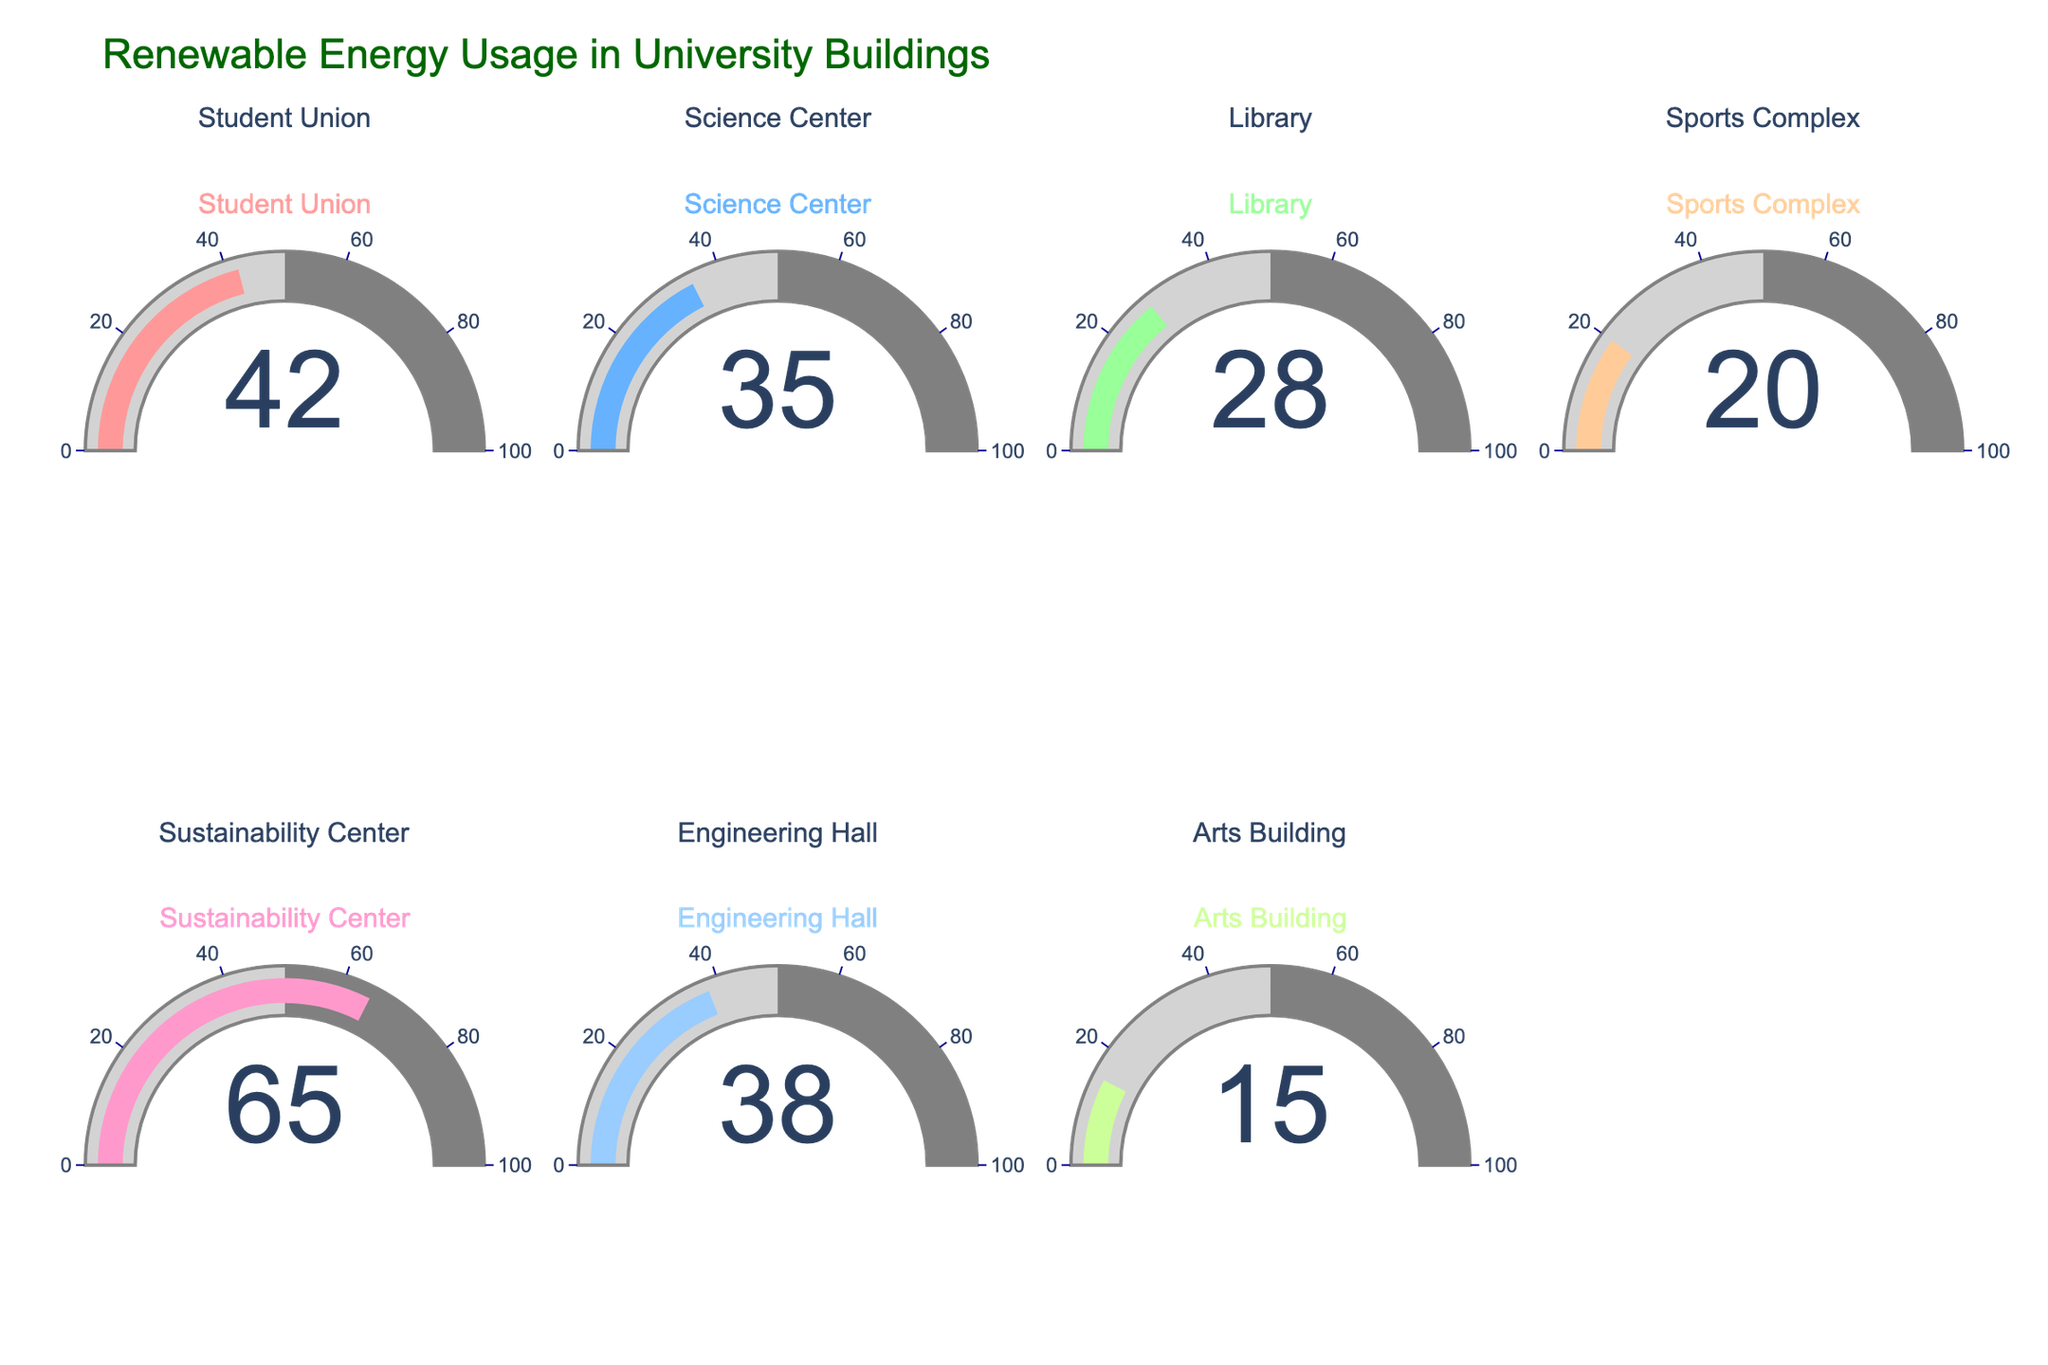What is the title of the figure? The title of the figure is always displayed prominently at the top. It helps give context to what the data visualization is about. In this case, it should summarize the entire chart.
Answer: Renewable Energy Usage in University Buildings Which building has the highest renewable energy usage? To find the building with the highest renewable energy usage, look for the gauge with the largest number. This gauge will indicate the building with the highest percentage.
Answer: Sustainability Center What is the renewable energy usage percentage in the Library? Locate the gauge labeled 'Library' and check the number displayed in the gauge to find the renewable energy usage percentage.
Answer: 28% What is the difference in renewable energy usage between the Student Union and the Arts Building? Identify the percentages of the Student Union and Arts Building from their respective gauges. Subtract the smaller number from the larger number. (42 - 15) = 27
Answer: 27% Is the renewable energy usage in the Science Center greater than that in the Engineering Hall? Compare the percentages on the gauges for the Science Center and Engineering Hall. Science Center has 35 and Engineering Hall has 38. Since 35 < 38, the usage in the Science Center is not greater.
Answer: No What is the average renewable energy usage across all the buildings? Add all the percentages together and divide by the number of buildings: (42 + 35 + 28 + 20 + 65 + 38 + 15) / 7 = 243 / 7 ≈ 34.71
Answer: ≈ 34.71% Which buildings have a renewable energy usage below 30%? Identify and list the buildings with gauges that show less than 30%. From the data, these would be Library, Sports Complex, and Arts Building.
Answer: Library, Sports Complex, Arts Building What is the combined renewable energy usage percentage of the Science Center and Sustainability Center? Sum the percentages of the Science Center (35) and Sustainability Center (65). 35 + 65 = 100
Answer: 100% Is the renewable energy usage in the Student Union less than the usage in the Sustainability Center? Compare the Student Union (42) and Sustainability Center (65) gauge values. Since 42 < 65, the usage in the Student Union is less.
Answer: Yes Which building has the least renewable energy usage and what is the percentage? Find the gauge with the smallest value to determine which building has the least renewable energy usage and read off the percentage. This would be the Arts Building at 15%.
Answer: Arts Building, 15% 